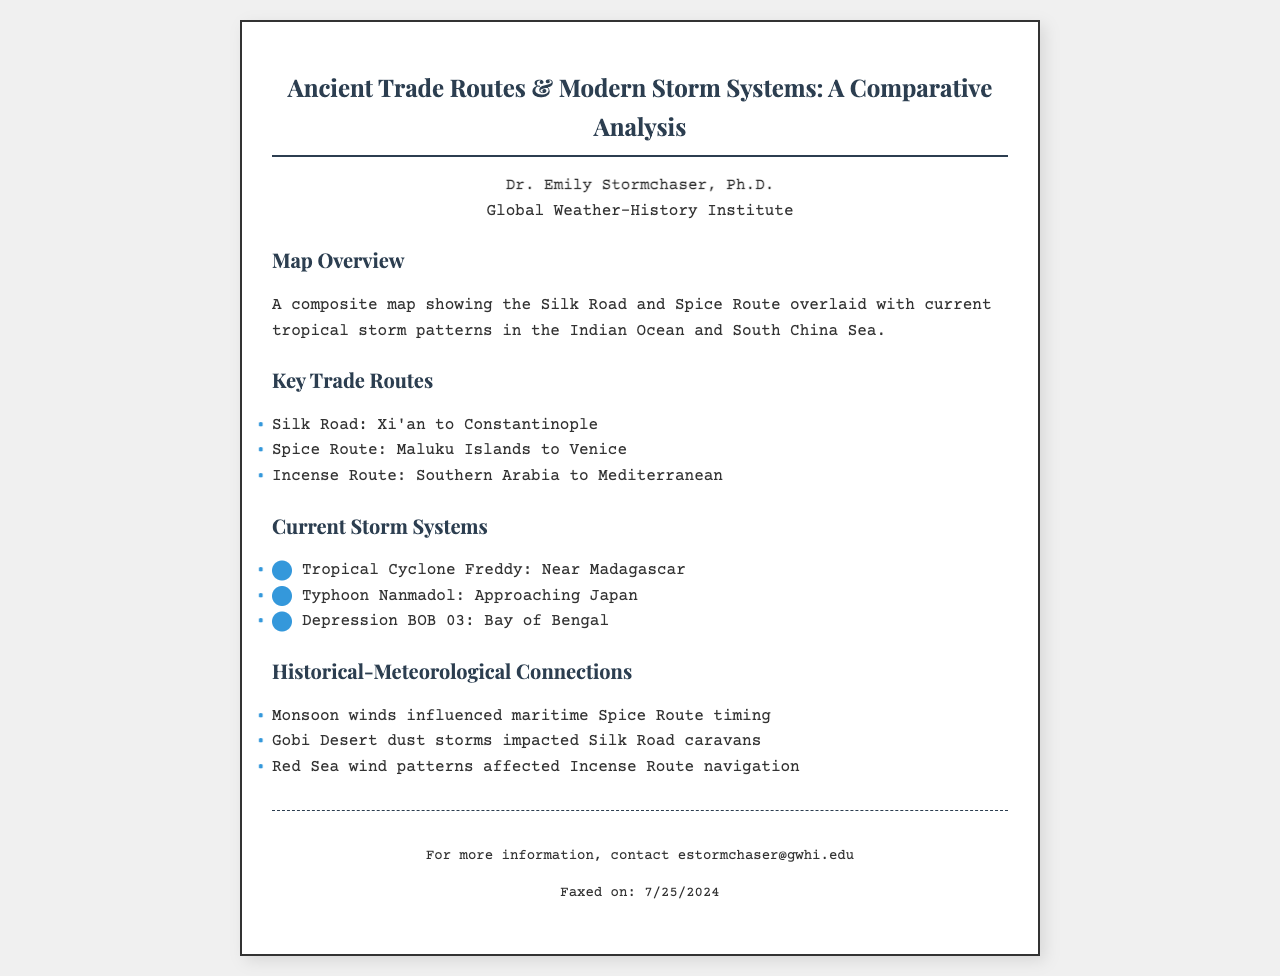What are the names of two ancient trade routes mentioned? The document lists the Silk Road and the Spice Route as key trade routes.
Answer: Silk Road, Spice Route Who is the author of the fax? The fax is authored by Dr. Emily Stormchaser, Ph.D., as stated in the header.
Answer: Dr. Emily Stormchaser, Ph.D What current storm system is near Madagascar? The document notes Tropical Cyclone Freddy as the storm system near Madagascar.
Answer: Tropical Cyclone Freddy Which route was influenced by monsoon winds? The reasoning aligns the Spice Route with the influence of monsoon winds on its timing, as stated in the connections section.
Answer: Spice Route What city marks the start of the Silk Road? The document specifies Xi'an as the starting point of the Silk Road.
Answer: Xi'an What date was the document faxed? The document indicates that the faxed date is dynamically generated and displayed in the footer.
Answer: [Current date] 